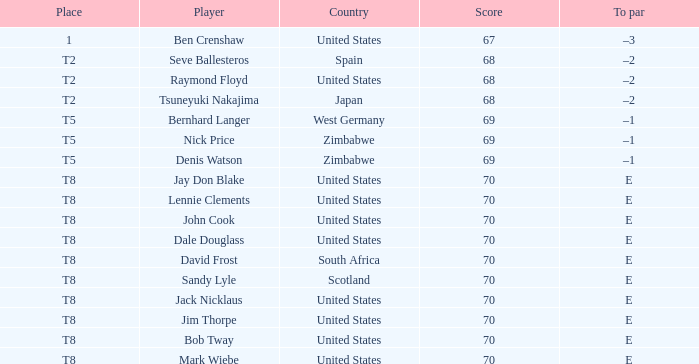What player has The United States as the country with 70 as the score? Jay Don Blake, Lennie Clements, John Cook, Dale Douglass, Jack Nicklaus, Jim Thorpe, Bob Tway, Mark Wiebe. 